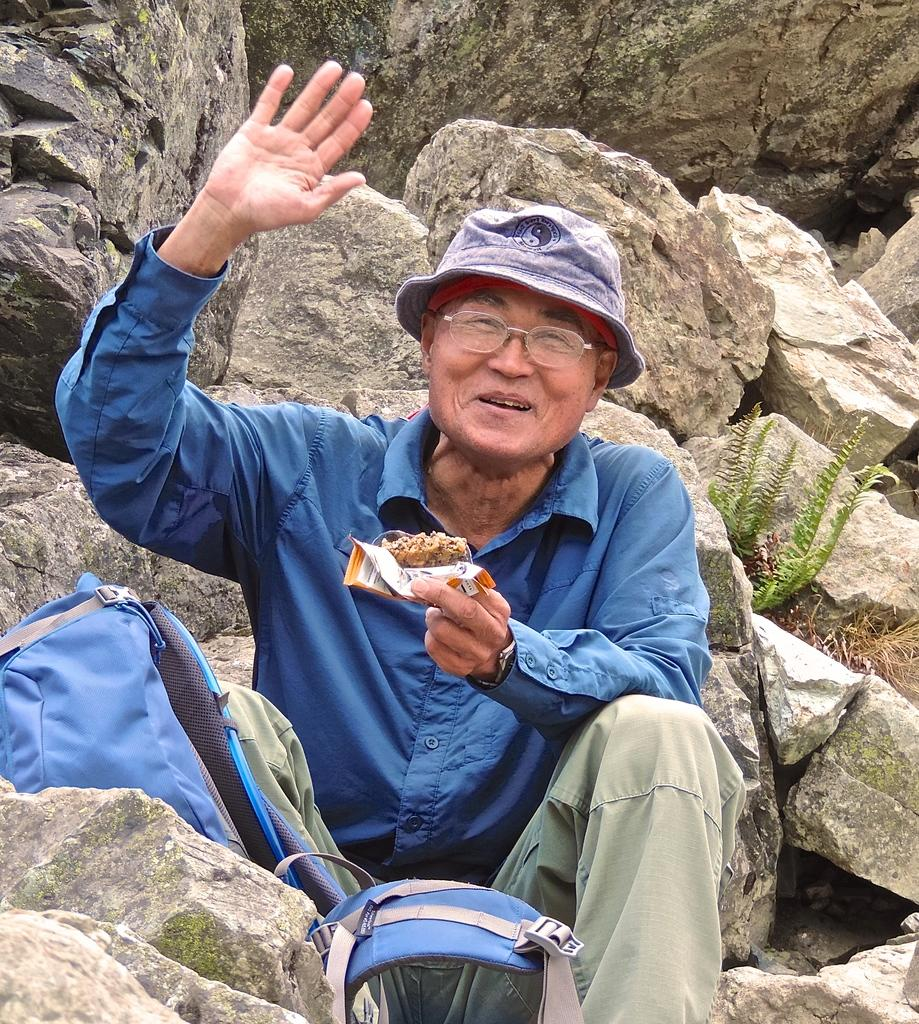What is the person in the image doing? There is a person sitting in the image. What is the person holding in the image? The person is holding a food item. What object is present in the image that might be used for carrying belongings? There is a backpack in the image. What type of natural feature can be seen in the image? There are rocks visible in the image. What type of living organism can be seen in the image? There is a plant in the image. What direction is the sleet coming from in the image? There is no mention of sleet in the image, so it cannot be determined from which direction it might be coming. 